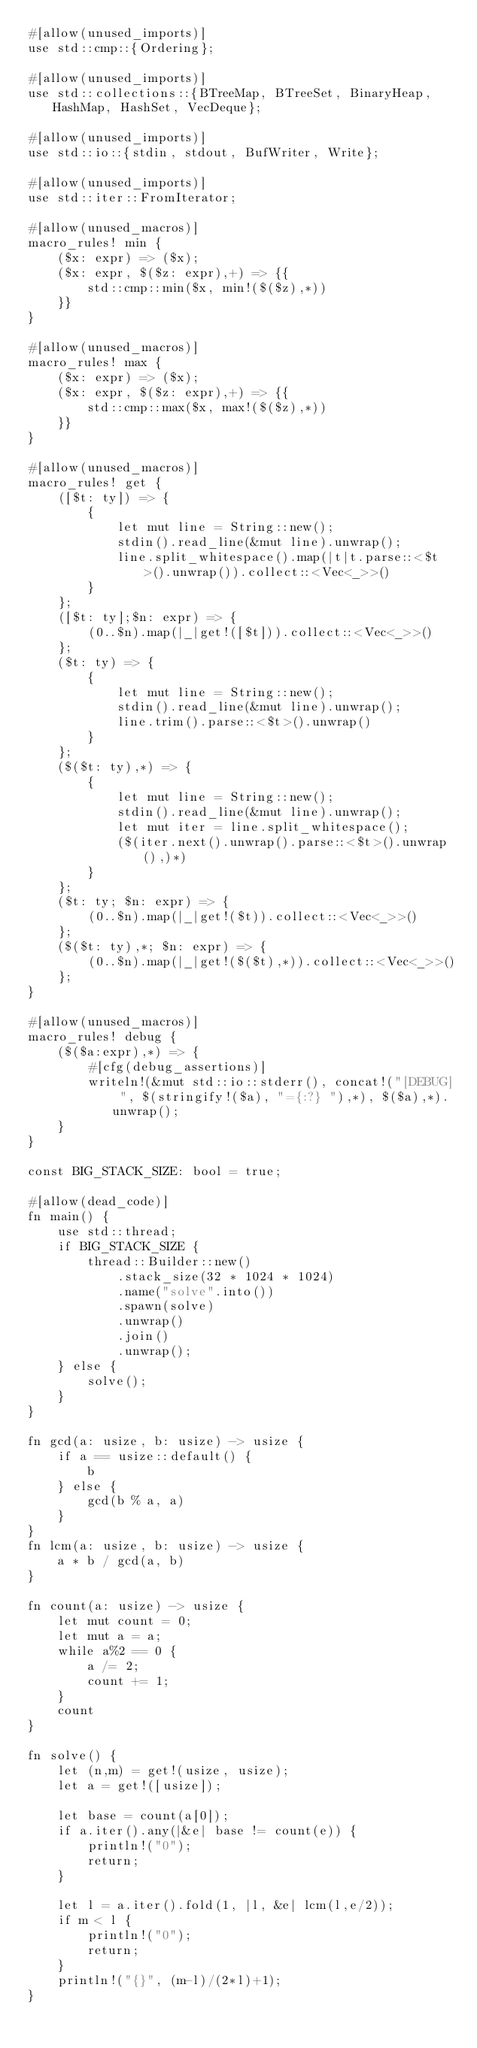<code> <loc_0><loc_0><loc_500><loc_500><_Rust_>#[allow(unused_imports)]
use std::cmp::{Ordering};

#[allow(unused_imports)]
use std::collections::{BTreeMap, BTreeSet, BinaryHeap, HashMap, HashSet, VecDeque};

#[allow(unused_imports)]
use std::io::{stdin, stdout, BufWriter, Write};

#[allow(unused_imports)]
use std::iter::FromIterator;

#[allow(unused_macros)]
macro_rules! min {
    ($x: expr) => ($x);
    ($x: expr, $($z: expr),+) => {{
        std::cmp::min($x, min!($($z),*))
    }}
}

#[allow(unused_macros)]
macro_rules! max {
    ($x: expr) => ($x);
    ($x: expr, $($z: expr),+) => {{
        std::cmp::max($x, max!($($z),*))
    }}
}

#[allow(unused_macros)]
macro_rules! get { 
    ([$t: ty]) => { 
        { 
            let mut line = String::new(); 
            stdin().read_line(&mut line).unwrap(); 
            line.split_whitespace().map(|t|t.parse::<$t>().unwrap()).collect::<Vec<_>>()
        }
    };
    ([$t: ty];$n: expr) => {
        (0..$n).map(|_|get!([$t])).collect::<Vec<_>>()
    };
    ($t: ty) => {
        {
            let mut line = String::new();
            stdin().read_line(&mut line).unwrap();
            line.trim().parse::<$t>().unwrap()
        }
    };
    ($($t: ty),*) => {
        { 
            let mut line = String::new();
            stdin().read_line(&mut line).unwrap();
            let mut iter = line.split_whitespace();
            ($(iter.next().unwrap().parse::<$t>().unwrap(),)*)
        }
    };
    ($t: ty; $n: expr) => {
        (0..$n).map(|_|get!($t)).collect::<Vec<_>>()
    };
    ($($t: ty),*; $n: expr) => {
        (0..$n).map(|_|get!($($t),*)).collect::<Vec<_>>()
    };
}

#[allow(unused_macros)]
macro_rules! debug {
    ($($a:expr),*) => {
        #[cfg(debug_assertions)]
        writeln!(&mut std::io::stderr(), concat!("[DEBUG] ", $(stringify!($a), "={:?} "),*), $($a),*).unwrap();
    }
}

const BIG_STACK_SIZE: bool = true;

#[allow(dead_code)]
fn main() {
    use std::thread;
    if BIG_STACK_SIZE {
        thread::Builder::new()
            .stack_size(32 * 1024 * 1024)
            .name("solve".into())
            .spawn(solve)
            .unwrap()
            .join()
            .unwrap();
    } else {
        solve();
    }
}

fn gcd(a: usize, b: usize) -> usize {
    if a == usize::default() {
        b
    } else {
        gcd(b % a, a)
    }
}
fn lcm(a: usize, b: usize) -> usize {
    a * b / gcd(a, b)
}

fn count(a: usize) -> usize {
    let mut count = 0;
    let mut a = a;
    while a%2 == 0 {
        a /= 2;
        count += 1;
    }
    count
}

fn solve() {
    let (n,m) = get!(usize, usize);
    let a = get!([usize]);

    let base = count(a[0]);
    if a.iter().any(|&e| base != count(e)) {
        println!("0");
        return;
    }

    let l = a.iter().fold(1, |l, &e| lcm(l,e/2));
    if m < l {
        println!("0");
        return;
    }
    println!("{}", (m-l)/(2*l)+1);
}
</code> 